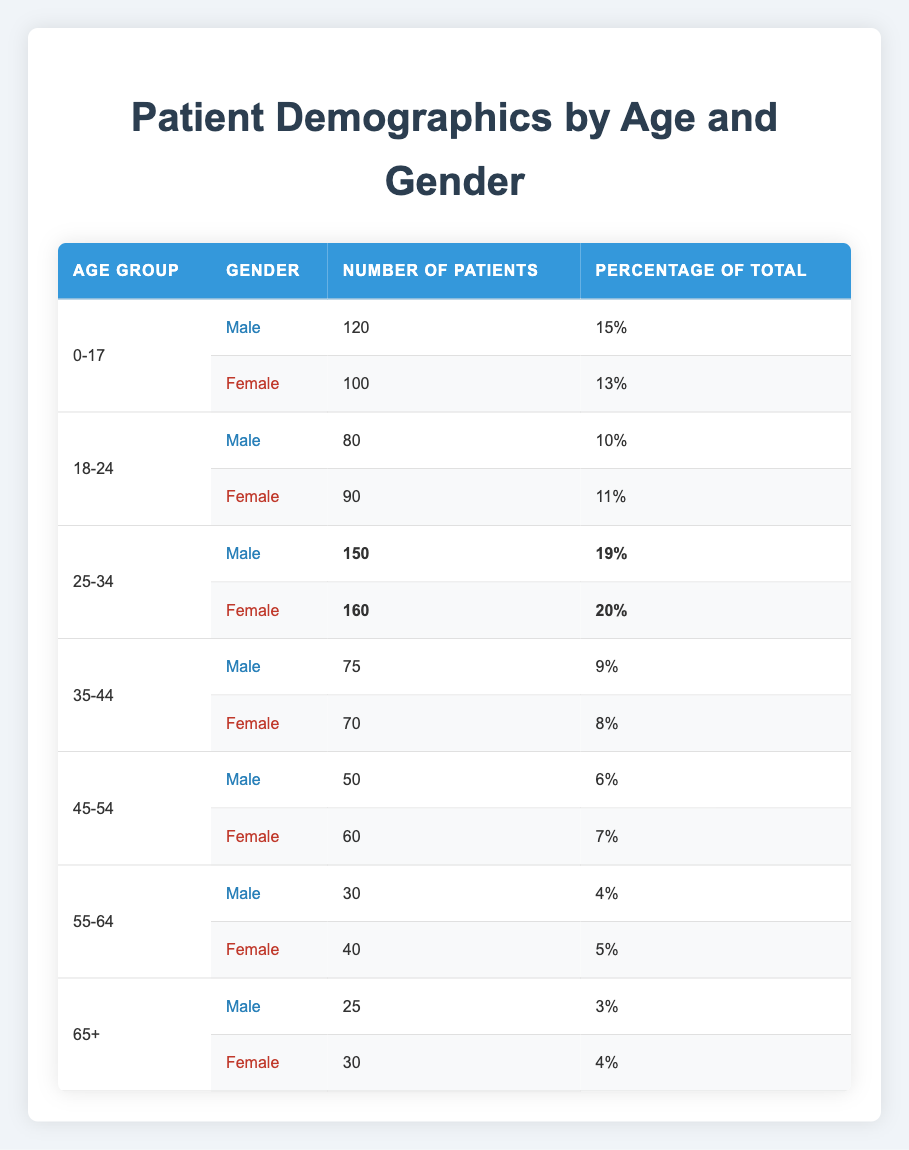What is the total number of male patients in the age group 25-34? In the age group 25-34, there are 150 male patients.
Answer: 150 What percentage of patients are aged 0-17? The percentage of patients aged 0-17 can be found by adding the percentages of male and female in this age group, which are 15% and 13%, respectively: 15% + 13% = 28%.
Answer: 28% How many more female patients are there than male patients in the age group 18-24? In the age group 18-24, there are 90 female patients and 80 male patients. To find the difference, subtract the number of male patients from the number of female patients: 90 - 80 = 10.
Answer: 10 What is the total number of patients aged 65 and older? In the age group 65+, there are 25 male patients and 30 female patients. Adding both gives: 25 + 30 = 55 patients in this age group.
Answer: 55 Is the number of female patients in the 25-34 age group greater than the number of male patients in the same age group? There are 160 female patients and 150 male patients in the 25-34 age group. Since 160 is greater than 150, the statement is true.
Answer: Yes What is the average number of patients across all age groups for males? To find the average for males, sum the number of male patients across all age groups (120 + 80 + 150 + 75 + 50 + 30 + 25 = 530) and divide by the number of age groups (7): 530 / 7 ≈ 75.71.
Answer: 75.71 What age group has the highest percentage of patients? Upon examining the percentage values, the age group 25-34 has the highest combined percentage of 39% (19% for male and 20% for female).
Answer: 25-34 How many patients aged 55-64 are there in total? In the age group 55-64, there are 30 male patients and 40 female patients. Adding these numbers gives: 30 + 40 = 70.
Answer: 70 What is the total percentage of patients aged 45-54? The total percentage of patients aged 45-54 is calculated by summing 6% (male) and 7% (female), giving 6% + 7% = 13%.
Answer: 13% Is it true that the number of patients aged 35-44 is less than the number of patients aged 18-24? The 35-44 age group has 75 male and 70 female patients (145 total), while the 18-24 age group has 80 male and 90 female patients (170 total). Since 145 is less than 170, the statement is true.
Answer: Yes 